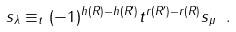<formula> <loc_0><loc_0><loc_500><loc_500>s _ { \lambda } \equiv _ { t } ( - 1 ) ^ { h ( R ) - h ( R ^ { \prime } ) } t ^ { r ( R ^ { \prime } ) - r ( R ) } s _ { \mu } \ .</formula> 